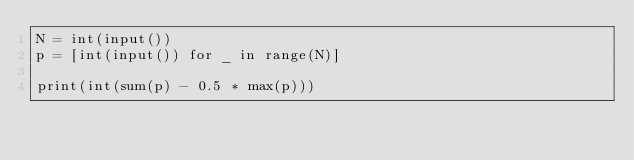<code> <loc_0><loc_0><loc_500><loc_500><_Python_>N = int(input())
p = [int(input()) for _ in range(N)]

print(int(sum(p) - 0.5 * max(p)))
</code> 